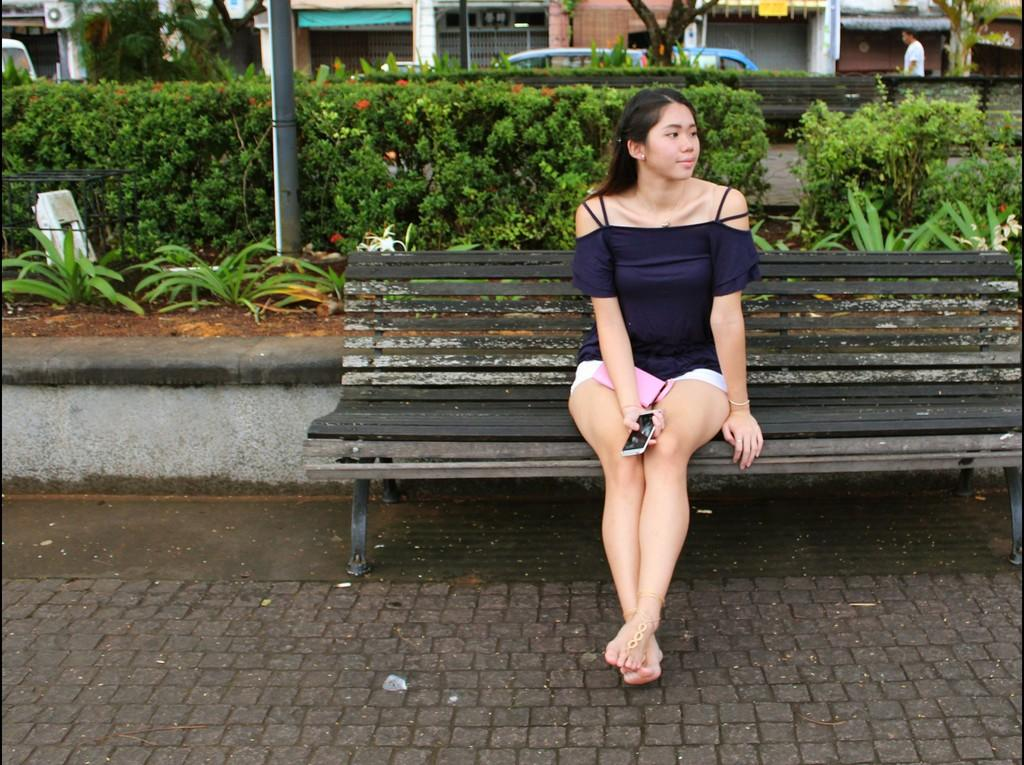What is the woman doing in the image? The woman is sitting on a wooden table in the image. What can be seen in the background of the image? There are plants and a car in the background of the image. What is the man in the background doing? The man is walking in the background of the image. Where is the man located in the image? The man is on the top right side of the image. How many quarters can be seen hanging from the plants in the image? There are no quarters visible in the image; it features a woman sitting on a wooden table, a man walking in the background, and plants and a car in the background. What type of spring is present in the image? There is no spring present in the image. 